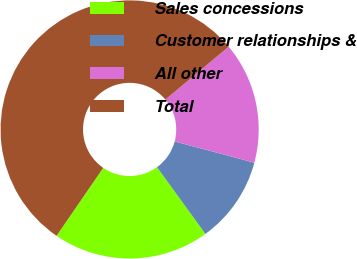Convert chart to OTSL. <chart><loc_0><loc_0><loc_500><loc_500><pie_chart><fcel>Sales concessions<fcel>Customer relationships &<fcel>All other<fcel>Total<nl><fcel>19.57%<fcel>10.87%<fcel>15.22%<fcel>54.35%<nl></chart> 